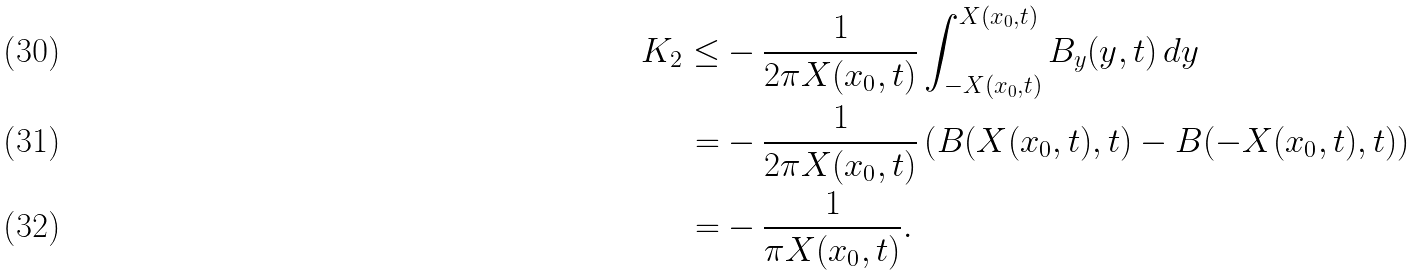Convert formula to latex. <formula><loc_0><loc_0><loc_500><loc_500>K _ { 2 } \leq & - \frac { 1 } { 2 \pi X ( x _ { 0 } , t ) } \int _ { - X ( x _ { 0 } , t ) } ^ { X ( x _ { 0 } , t ) } B _ { y } ( y , t ) \, d y \\ = & - \frac { 1 } { 2 \pi X ( x _ { 0 } , t ) } \left ( B ( X ( x _ { 0 } , t ) , t ) - B ( - X ( x _ { 0 } , t ) , t ) \right ) \\ = & - \frac { 1 } { \pi X ( x _ { 0 } , t ) } .</formula> 